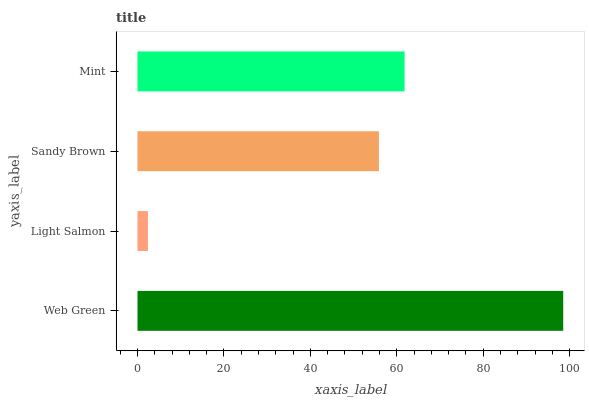Is Light Salmon the minimum?
Answer yes or no. Yes. Is Web Green the maximum?
Answer yes or no. Yes. Is Sandy Brown the minimum?
Answer yes or no. No. Is Sandy Brown the maximum?
Answer yes or no. No. Is Sandy Brown greater than Light Salmon?
Answer yes or no. Yes. Is Light Salmon less than Sandy Brown?
Answer yes or no. Yes. Is Light Salmon greater than Sandy Brown?
Answer yes or no. No. Is Sandy Brown less than Light Salmon?
Answer yes or no. No. Is Mint the high median?
Answer yes or no. Yes. Is Sandy Brown the low median?
Answer yes or no. Yes. Is Sandy Brown the high median?
Answer yes or no. No. Is Web Green the low median?
Answer yes or no. No. 